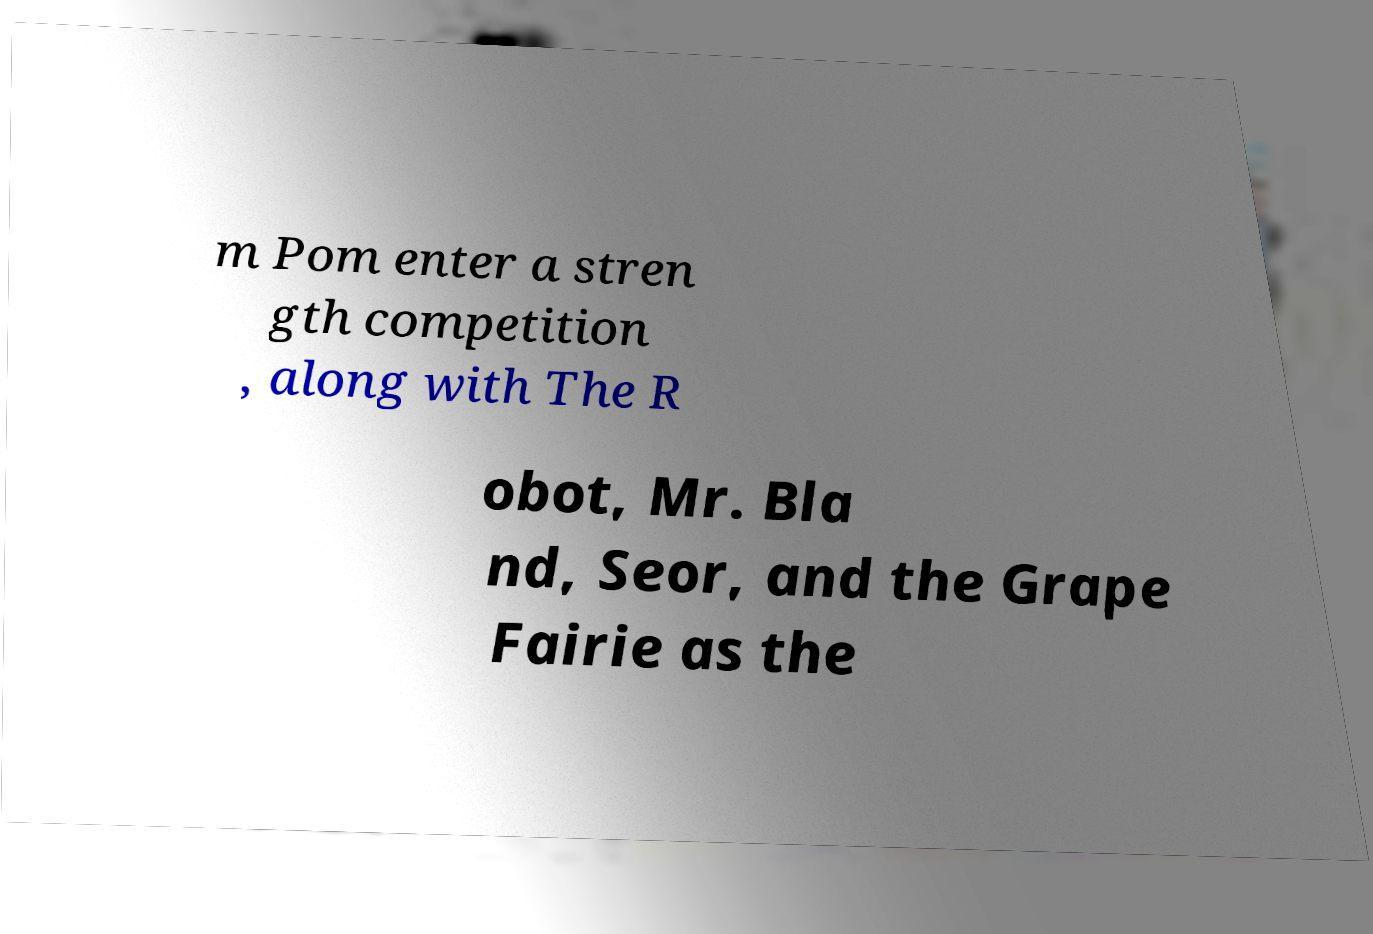Can you read and provide the text displayed in the image?This photo seems to have some interesting text. Can you extract and type it out for me? m Pom enter a stren gth competition , along with The R obot, Mr. Bla nd, Seor, and the Grape Fairie as the 